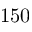Convert formula to latex. <formula><loc_0><loc_0><loc_500><loc_500>1 5 0</formula> 